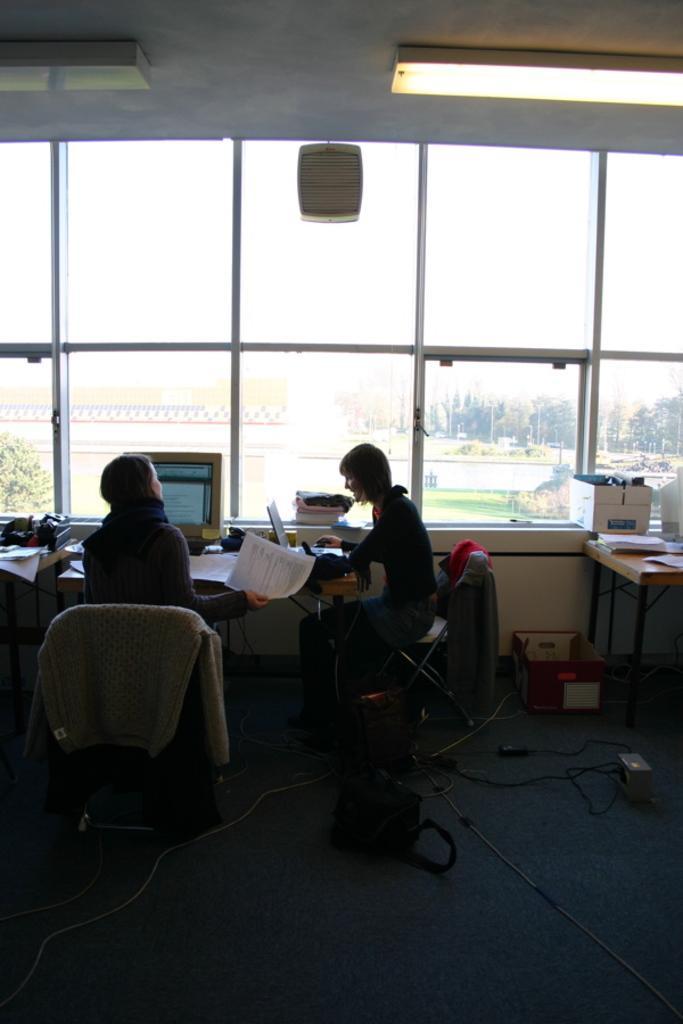How would you summarize this image in a sentence or two? In this image we can see people sitting on the chairs near the table. In the background we can see glass windows through which trees and building can be seen. 